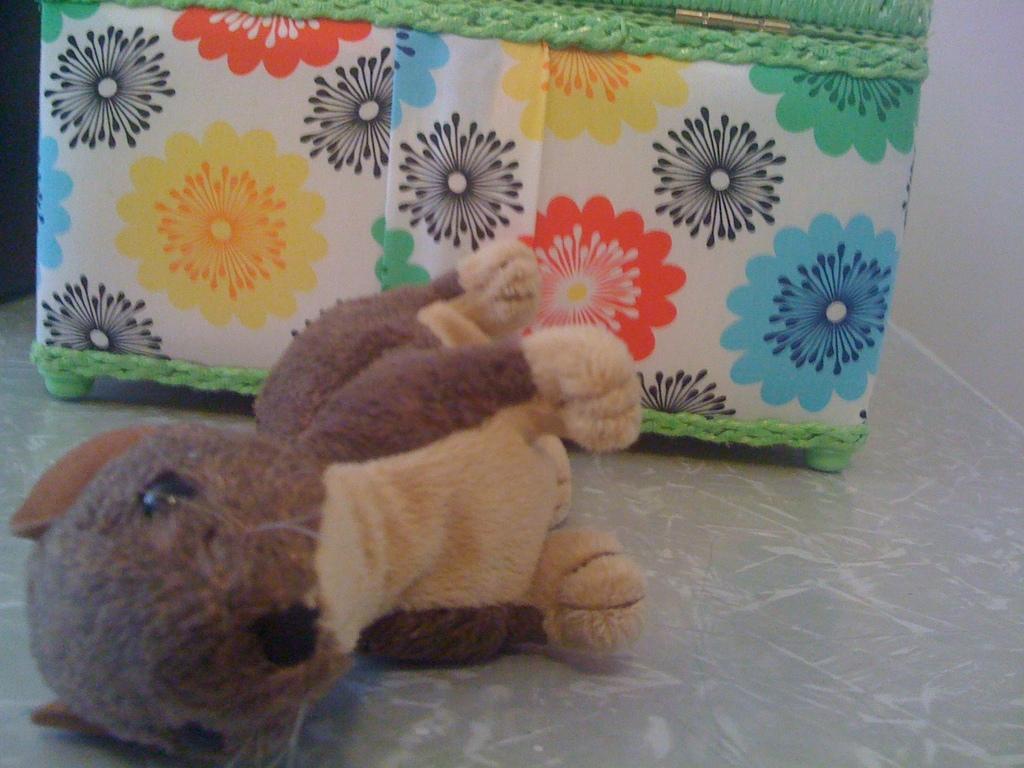How would you summarize this image in a sentence or two? In this picture there is a doll on the floor. Beside that we can see a box which is near to the wall. 